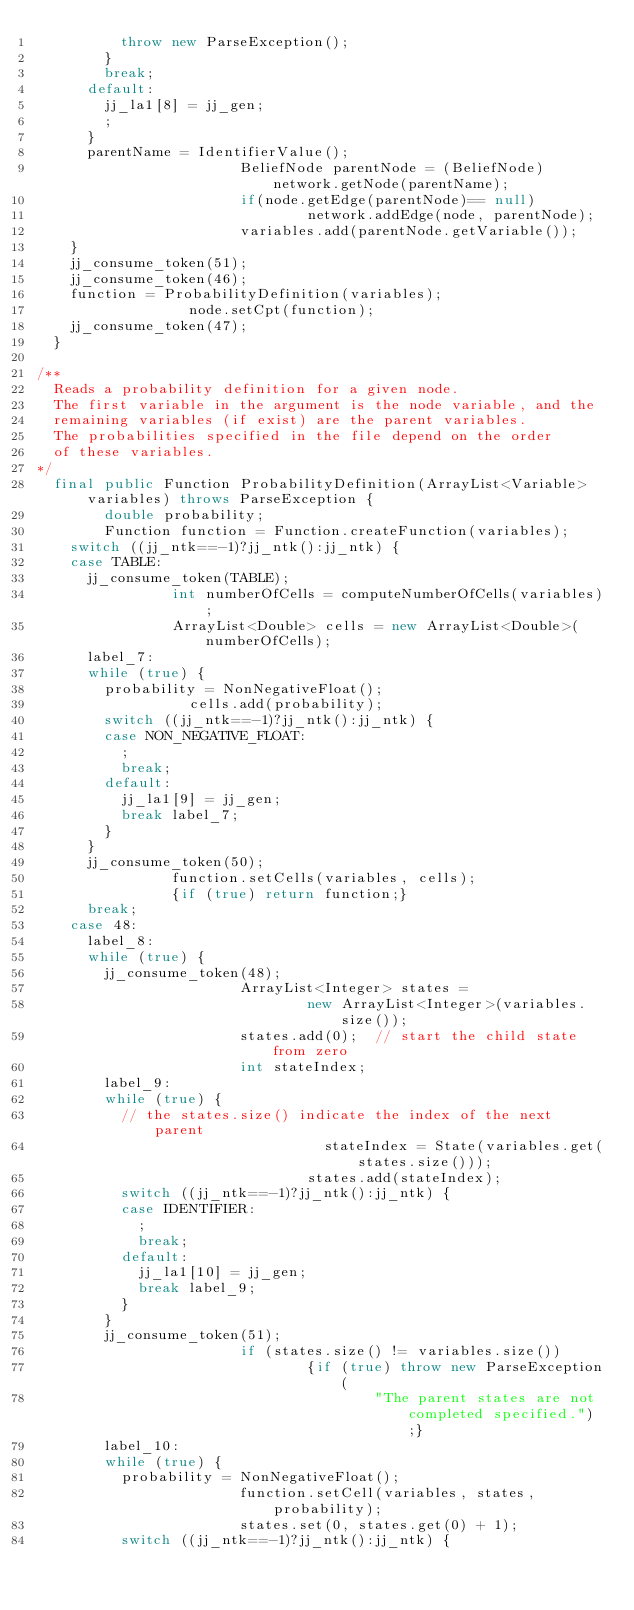Convert code to text. <code><loc_0><loc_0><loc_500><loc_500><_Java_>          throw new ParseException();
        }
        break;
      default:
        jj_la1[8] = jj_gen;
        ;
      }
      parentName = IdentifierValue();
                        BeliefNode parentNode = (BeliefNode) network.getNode(parentName);
                        if(node.getEdge(parentNode)== null)
                                network.addEdge(node, parentNode);
                        variables.add(parentNode.getVariable());
    }
    jj_consume_token(51);
    jj_consume_token(46);
    function = ProbabilityDefinition(variables);
                  node.setCpt(function);
    jj_consume_token(47);
  }

/**
	Reads a probability definition for a given node.
	The first variable in the argument is the node variable, and the
	remaining variables (if exist) are the parent variables.
	The probabilities specified in the file depend on the order 
	of these variables.
*/
  final public Function ProbabilityDefinition(ArrayList<Variable> variables) throws ParseException {
        double probability;
        Function function = Function.createFunction(variables);
    switch ((jj_ntk==-1)?jj_ntk():jj_ntk) {
    case TABLE:
      jj_consume_token(TABLE);
                int numberOfCells = computeNumberOfCells(variables);
                ArrayList<Double> cells = new ArrayList<Double>(numberOfCells);
      label_7:
      while (true) {
        probability = NonNegativeFloat();
                  cells.add(probability);
        switch ((jj_ntk==-1)?jj_ntk():jj_ntk) {
        case NON_NEGATIVE_FLOAT:
          ;
          break;
        default:
          jj_la1[9] = jj_gen;
          break label_7;
        }
      }
      jj_consume_token(50);
                function.setCells(variables, cells);
                {if (true) return function;}
      break;
    case 48:
      label_8:
      while (true) {
        jj_consume_token(48);
                        ArrayList<Integer> states =
                                new ArrayList<Integer>(variables.size());
                        states.add(0);  // start the child state from zero
                        int stateIndex;
        label_9:
        while (true) {
          // the states.size() indicate the index of the next parent
                                  stateIndex = State(variables.get(states.size()));
                                states.add(stateIndex);
          switch ((jj_ntk==-1)?jj_ntk():jj_ntk) {
          case IDENTIFIER:
            ;
            break;
          default:
            jj_la1[10] = jj_gen;
            break label_9;
          }
        }
        jj_consume_token(51);
                        if (states.size() != variables.size())
                                {if (true) throw new ParseException(
                                        "The parent states are not completed specified.");}
        label_10:
        while (true) {
          probability = NonNegativeFloat();
                        function.setCell(variables, states, probability);
                        states.set(0, states.get(0) + 1);
          switch ((jj_ntk==-1)?jj_ntk():jj_ntk) {</code> 